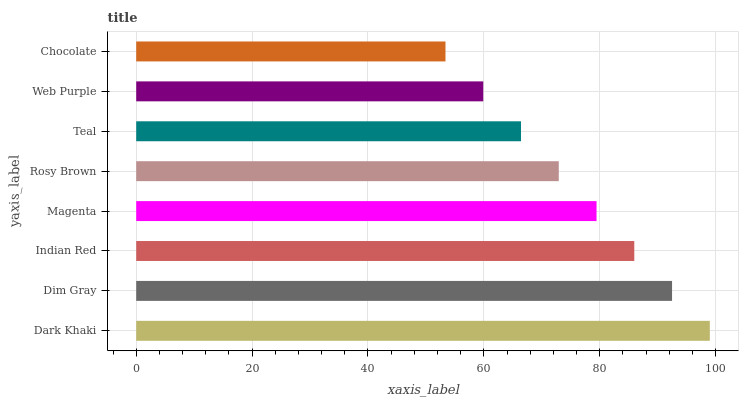Is Chocolate the minimum?
Answer yes or no. Yes. Is Dark Khaki the maximum?
Answer yes or no. Yes. Is Dim Gray the minimum?
Answer yes or no. No. Is Dim Gray the maximum?
Answer yes or no. No. Is Dark Khaki greater than Dim Gray?
Answer yes or no. Yes. Is Dim Gray less than Dark Khaki?
Answer yes or no. Yes. Is Dim Gray greater than Dark Khaki?
Answer yes or no. No. Is Dark Khaki less than Dim Gray?
Answer yes or no. No. Is Magenta the high median?
Answer yes or no. Yes. Is Rosy Brown the low median?
Answer yes or no. Yes. Is Dark Khaki the high median?
Answer yes or no. No. Is Indian Red the low median?
Answer yes or no. No. 